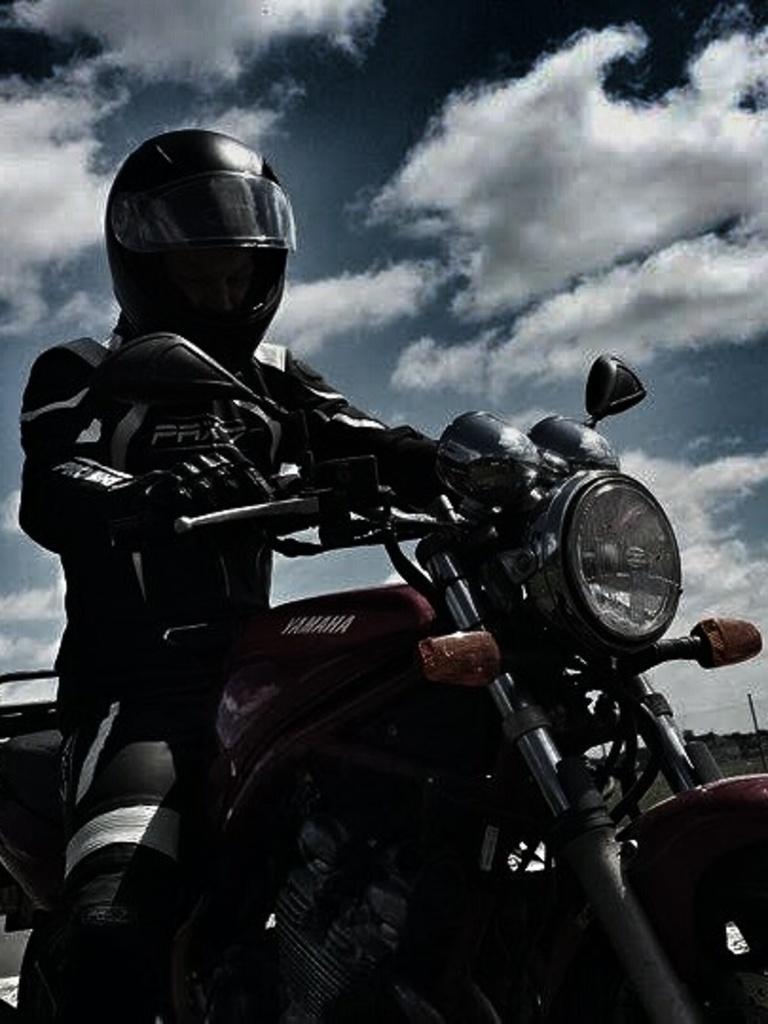Could you give a brief overview of what you see in this image? We can see sky with cloud. Here we can see one man riding a bike. He wore helmet. 